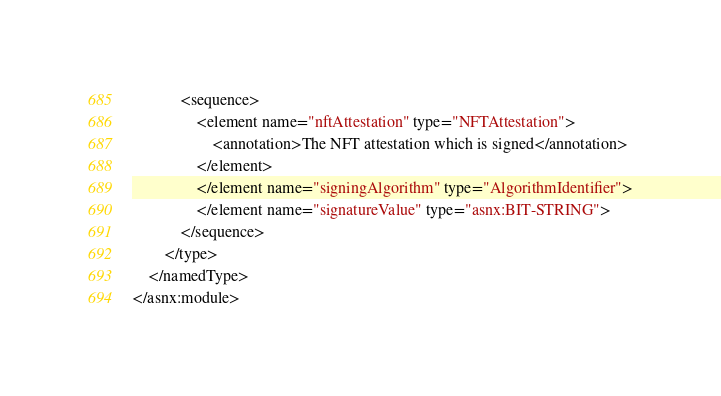<code> <loc_0><loc_0><loc_500><loc_500><_Lisp_>            <sequence>
                <element name="nftAttestation" type="NFTAttestation">
                    <annotation>The NFT attestation which is signed</annotation>
                </element>
                </element name="signingAlgorithm" type="AlgorithmIdentifier">
                </element name="signatureValue" type="asnx:BIT-STRING">
            </sequence>
        </type>
    </namedType>
</asnx:module>
</code> 